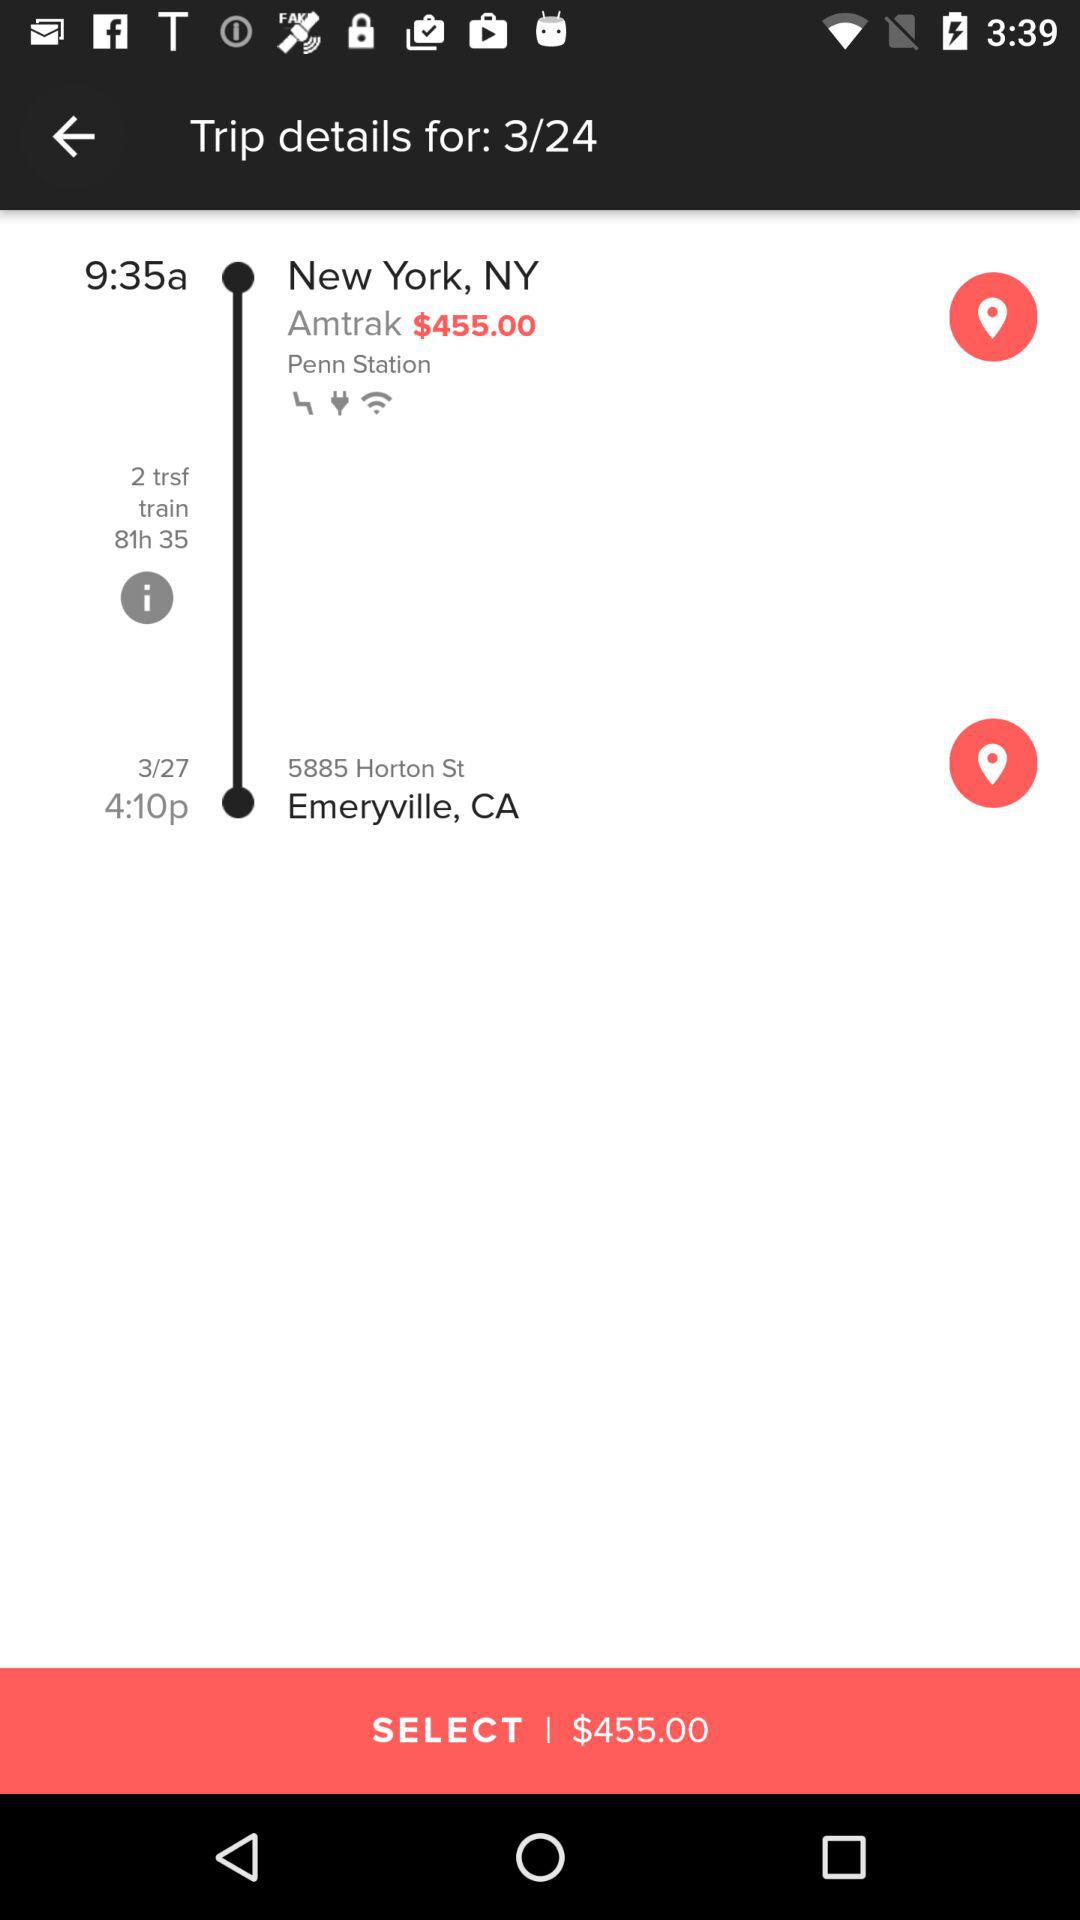What is the station name in New York? The station name is Penn. 